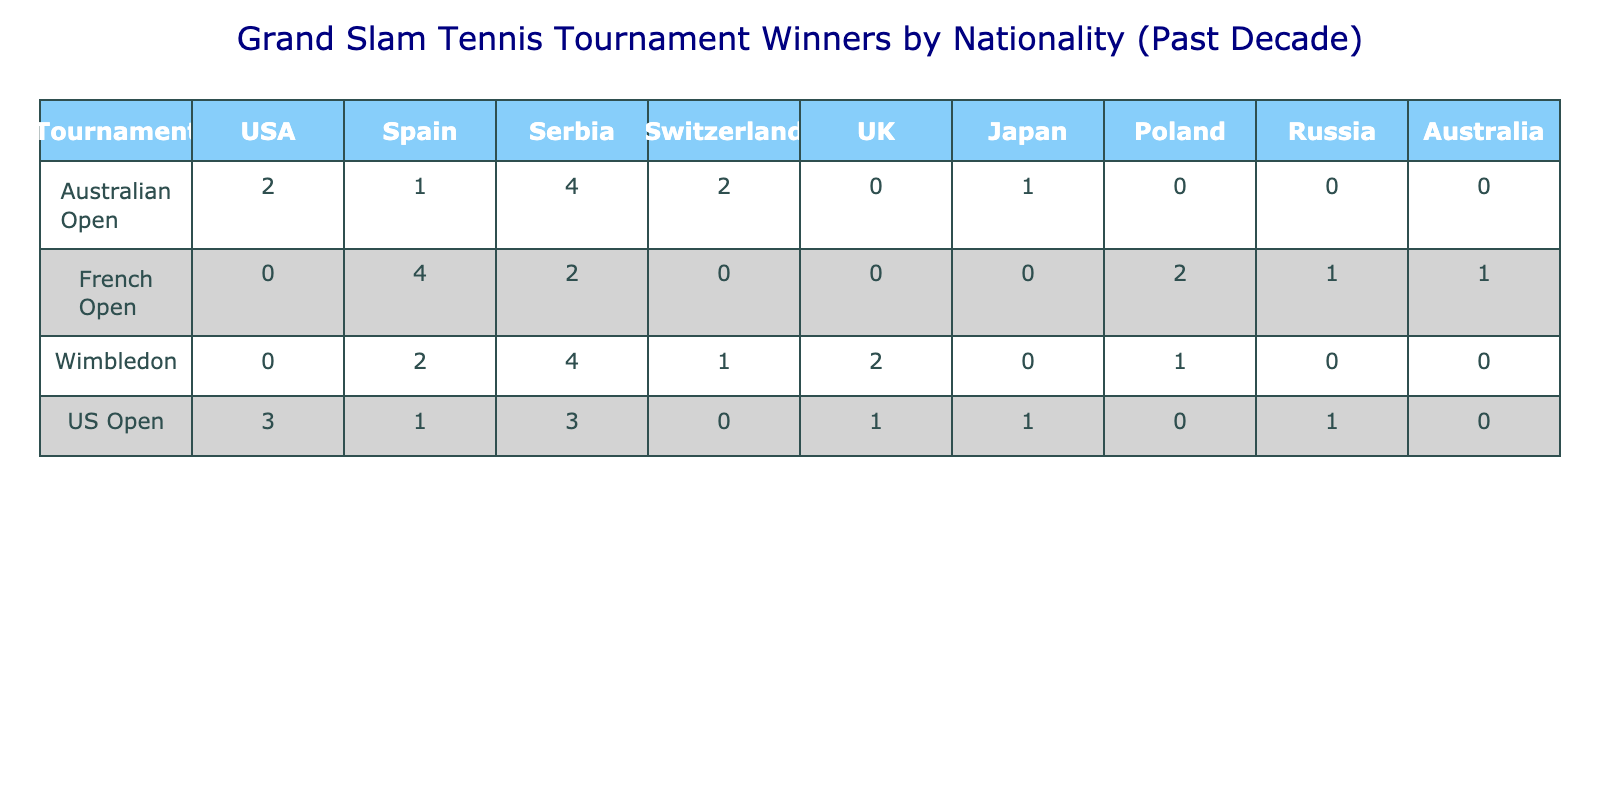What country won the most Australian Open titles in the past decade? According to the table, the USA won 2 titles, Spain won 1, Serbia won 4, Switzerland won 2, and there were no titles for the UK, Japan, Poland, Russia, and Australia. Hence, Serbia is the country that won the most titles with 4.
Answer: Serbia How many titles did Japan win across all tournaments in the last decade? In the table, Japan won 1 title in the Australian Open, 0 in the French Open, 0 in Wimbledon, and 1 in the US Open. Adding these up, we have 1 + 0 + 0 + 1 = 2 titles in total.
Answer: 2 Which tournament had the least number of winners from Spain? Looking at the table, Spain has 1 title in the Australian Open and 2 in Wimbledon, while it has 4 in the French Open and 1 in the US Open. Therefore, the Australian Open and the US Open both had the least number of wins from Spain, with 1 title each.
Answer: Australian Open and US Open What is the total number of French Open titles won by Serbia and Spain combined? Serbia won 2 titles and Spain won 4 titles in the French Open. Combining these yields 2 + 4 = 6 total titles won by both countries.
Answer: 6 Did the UK win more Wimbledon titles than the US Open titles in the past decade? The UK won 2 titles in Wimbledon and 1 title in the US Open. Since 2 is greater than 1, the answer is yes, the UK won more titles in Wimbledon than in the US Open.
Answer: Yes How many more titles did Serbia win compared to the USA in all tournaments combined? Serbia won 4 (Australian Open) + 2 (French Open) + 4 (Wimbledon) + 3 (US Open) = 13 total titles. The USA won 2 (Australian Open) + 0 (French Open) + 0 (Wimbledon) + 3 (US Open) = 5 total titles. The difference is 13 - 5 = 8 titles.
Answer: 8 Which country won the most total titles among all tournaments combined? Adding up the titles for all countries: Serbia has 13, Spain has 7, USA has 5, Switzerland has 3, the UK has 3, Japan has 2, Poland has 2, Russia has 1, and Australia has 0. Thus, Serbia won the most with 13 titles.
Answer: Serbia What percentage of the titles in the US Open were won by the USA? The USA won 3 titles in the US Open, while the total number of titles is 3 (USA) + 1 (Spain) + 1 (Serbia) + 1 (UK) + 1 (Japan) + 1 (Russia) + 0 (Switzerland) = 8 titles. The percentage is calculated as (3/8) * 100 = 37.5%.
Answer: 37.5% What is the average number of titles won by Russian players across all tournaments? Russia won 0 titles in the Australian Open, 1 in the French Open, 0 in Wimbledon, and 0 in the US Open. Thus, the average is calculated as (0 + 1 + 0 + 0) / 4 = 0.25.
Answer: 0.25 